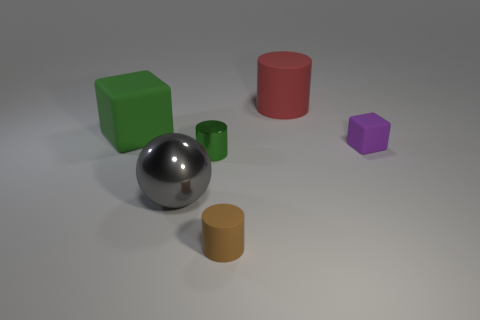There is a big object that is to the right of the large green cube and in front of the red thing; what is its material? metal 